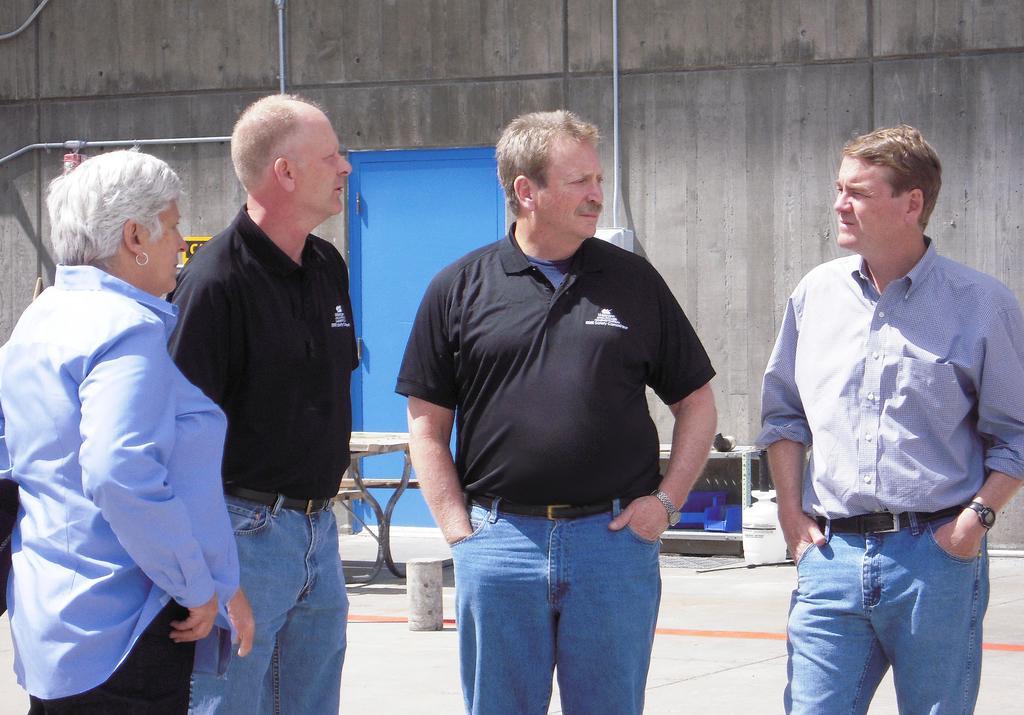Could you give a brief overview of what you see in this image? There are four people standing and talking to each other. At background I can see a blue colored door and a table. This looks like a building wall. 